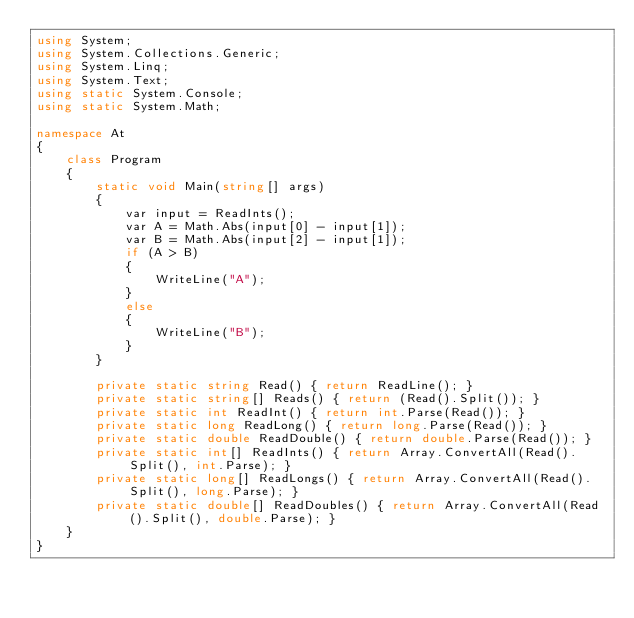<code> <loc_0><loc_0><loc_500><loc_500><_C#_>using System;
using System.Collections.Generic;
using System.Linq;
using System.Text;
using static System.Console;
using static System.Math;

namespace At
{
    class Program
    {
        static void Main(string[] args)
        {
            var input = ReadInts();
            var A = Math.Abs(input[0] - input[1]);
            var B = Math.Abs(input[2] - input[1]);
            if (A > B)
            {
                WriteLine("A");
            }
            else
            {
                WriteLine("B");
            }
        }

        private static string Read() { return ReadLine(); }
        private static string[] Reads() { return (Read().Split()); }
        private static int ReadInt() { return int.Parse(Read()); }
        private static long ReadLong() { return long.Parse(Read()); }
        private static double ReadDouble() { return double.Parse(Read()); }
        private static int[] ReadInts() { return Array.ConvertAll(Read().Split(), int.Parse); }
        private static long[] ReadLongs() { return Array.ConvertAll(Read().Split(), long.Parse); }
        private static double[] ReadDoubles() { return Array.ConvertAll(Read().Split(), double.Parse); }
    }
}
</code> 